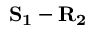Convert formula to latex. <formula><loc_0><loc_0><loc_500><loc_500>S _ { 1 } - R _ { 2 }</formula> 